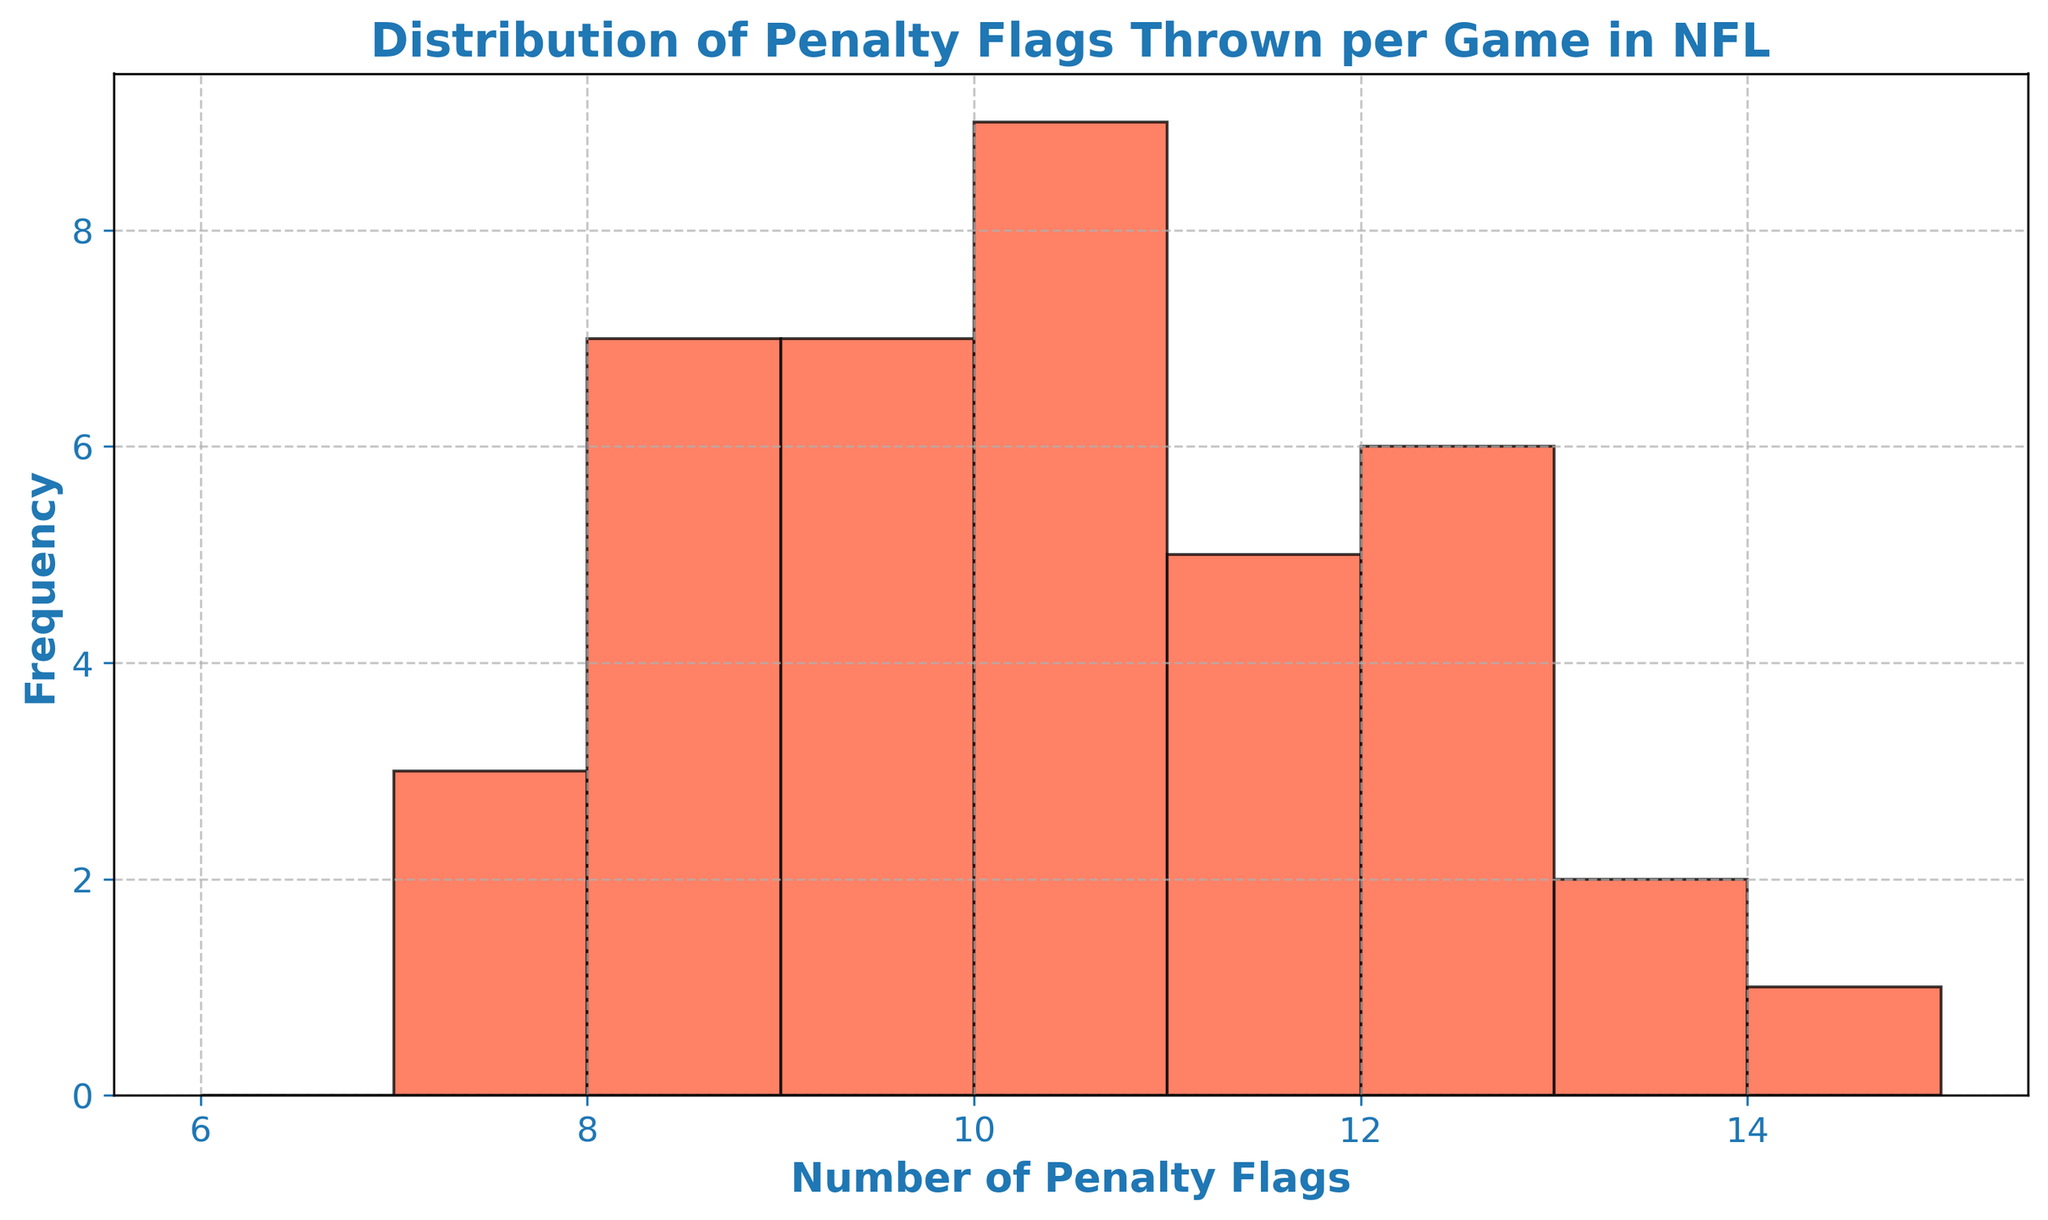What is the most frequent number of penalty flags thrown per game? The most frequent number is the one belonging to the tallest bar in the histogram. In this figure, the tallest bar corresponds to 10 penalty flags.
Answer: 10 Which number of penalty flags has the least frequency? The least frequent number corresponds to the shortest bar. In this histogram, the shortest bar represents 7 penalty flags.
Answer: 7 How many games had exactly 12 penalty flags thrown? We need to look at the height of the bar corresponding to 12 penalty flags. The label on the y-axis tells us the frequency. There are 6 games with 12 penalty flags.
Answer: 6 Which number of penalty flags appears more frequently, 8 or 13? By comparing the heights of the bars for 8 and 13 penalty flags, we see that the bar for 8 is taller.
Answer: 8 What is the total number of games that had between 10 and 12 penalty flags thrown? Sum the frequencies of the bars corresponding to 10, 11, and 12 penalty flags. The bars' heights indicate 7, 5, and 6 games respectively. Hence, the total is 7 + 5 + 6 = 18 games.
Answer: 18 Are there more games with fewer than 9 penalty flags or more than 11 penalty flags? We check the bars for fewer than 9 penalty flags (7 and 8) and sum their frequencies which are 3+6=9. For more than 11 penalty flags (12, 13, 14), sum their frequencies which are 6+2+1=9. Both are equal.
Answer: Equal What is the range of penalty flags thrown in these games? The range is the difference between the maximum and minimum number of penalty flags represented in the histogram. The minimum is 7 and the maximum is 14, so the range is 14 - 7 = 7.
Answer: 7 Which number of penalty flags is closer in frequency to the number with the highest frequency? First identify the number with the highest frequency, which is 10 penalty flags (with 7 occurrences). Compare the frequencies of the nearest values (9 and 11). Both have 5 occurrences, so both are equally close.
Answer: 9 and 11 What is the frequency of games with fewer than or equal to 8 penalty flags? Sum the frequencies for penalty flags 7 and 8. The heights of the bars are 3 for 7 penalty flags and 6 for 8 penalty flags. So, 3 + 6 = 9 games.
Answer: 9 